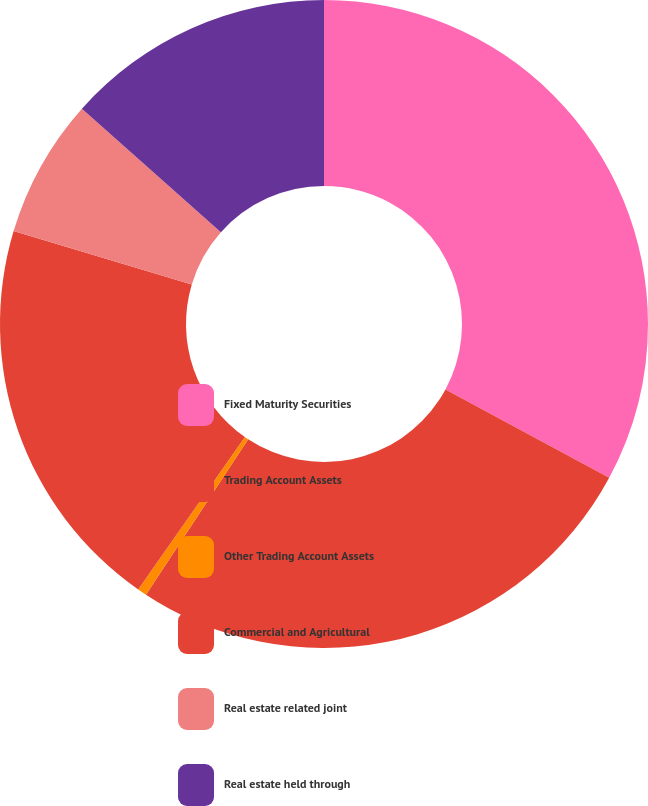Convert chart. <chart><loc_0><loc_0><loc_500><loc_500><pie_chart><fcel>Fixed Maturity Securities<fcel>Trading Account Assets<fcel>Other Trading Account Assets<fcel>Commercial and Agricultural<fcel>Real estate related joint<fcel>Real estate held through<nl><fcel>32.87%<fcel>26.39%<fcel>0.46%<fcel>19.91%<fcel>6.94%<fcel>13.43%<nl></chart> 